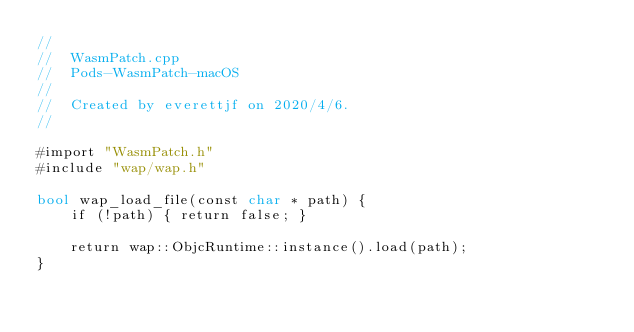<code> <loc_0><loc_0><loc_500><loc_500><_ObjectiveC_>//
//  WasmPatch.cpp
//  Pods-WasmPatch-macOS
//
//  Created by everettjf on 2020/4/6.
//

#import "WasmPatch.h"
#include "wap/wap.h"

bool wap_load_file(const char * path) {
    if (!path) { return false; }
    
    return wap::ObjcRuntime::instance().load(path);
}
</code> 